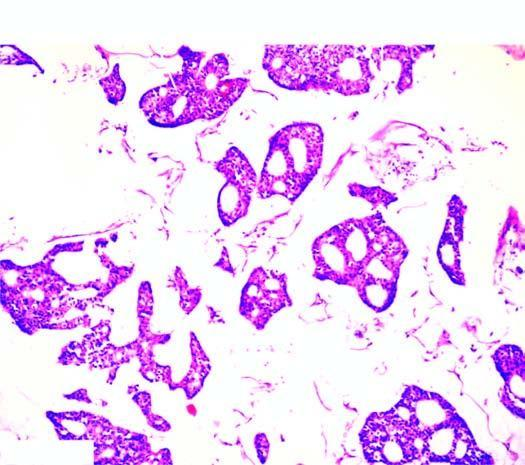what are seen as clusters floating in pools of abundant mucin?
Answer the question using a single word or phrase. Tumour cells 